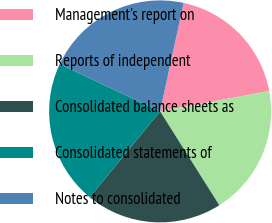Convert chart to OTSL. <chart><loc_0><loc_0><loc_500><loc_500><pie_chart><fcel>Management's report on<fcel>Reports of independent<fcel>Consolidated balance sheets as<fcel>Consolidated statements of<fcel>Notes to consolidated<nl><fcel>18.67%<fcel>18.98%<fcel>19.88%<fcel>21.08%<fcel>21.39%<nl></chart> 